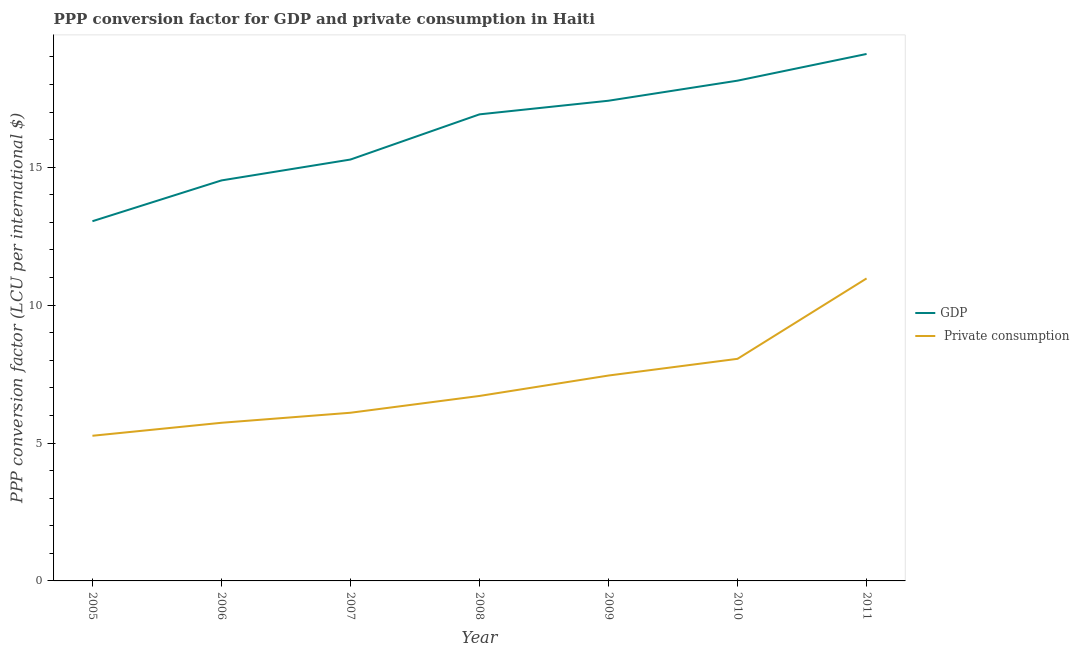How many different coloured lines are there?
Provide a short and direct response. 2. Is the number of lines equal to the number of legend labels?
Give a very brief answer. Yes. What is the ppp conversion factor for private consumption in 2011?
Your response must be concise. 10.97. Across all years, what is the maximum ppp conversion factor for gdp?
Provide a succinct answer. 19.11. Across all years, what is the minimum ppp conversion factor for gdp?
Keep it short and to the point. 13.04. In which year was the ppp conversion factor for gdp minimum?
Offer a very short reply. 2005. What is the total ppp conversion factor for gdp in the graph?
Offer a terse response. 114.43. What is the difference between the ppp conversion factor for private consumption in 2008 and that in 2011?
Offer a terse response. -4.26. What is the difference between the ppp conversion factor for private consumption in 2007 and the ppp conversion factor for gdp in 2008?
Make the answer very short. -10.82. What is the average ppp conversion factor for gdp per year?
Your response must be concise. 16.35. In the year 2011, what is the difference between the ppp conversion factor for private consumption and ppp conversion factor for gdp?
Make the answer very short. -8.14. What is the ratio of the ppp conversion factor for private consumption in 2007 to that in 2008?
Your answer should be compact. 0.91. Is the ppp conversion factor for private consumption in 2005 less than that in 2009?
Your answer should be very brief. Yes. Is the difference between the ppp conversion factor for private consumption in 2006 and 2007 greater than the difference between the ppp conversion factor for gdp in 2006 and 2007?
Offer a terse response. Yes. What is the difference between the highest and the second highest ppp conversion factor for gdp?
Ensure brevity in your answer.  0.97. What is the difference between the highest and the lowest ppp conversion factor for gdp?
Provide a short and direct response. 6.06. In how many years, is the ppp conversion factor for private consumption greater than the average ppp conversion factor for private consumption taken over all years?
Your answer should be compact. 3. Is the sum of the ppp conversion factor for private consumption in 2007 and 2011 greater than the maximum ppp conversion factor for gdp across all years?
Offer a very short reply. No. Is the ppp conversion factor for private consumption strictly less than the ppp conversion factor for gdp over the years?
Give a very brief answer. Yes. How many years are there in the graph?
Offer a terse response. 7. What is the difference between two consecutive major ticks on the Y-axis?
Provide a succinct answer. 5. Are the values on the major ticks of Y-axis written in scientific E-notation?
Offer a terse response. No. Does the graph contain grids?
Give a very brief answer. No. What is the title of the graph?
Keep it short and to the point. PPP conversion factor for GDP and private consumption in Haiti. Does "Taxes on exports" appear as one of the legend labels in the graph?
Your answer should be compact. No. What is the label or title of the Y-axis?
Your answer should be compact. PPP conversion factor (LCU per international $). What is the PPP conversion factor (LCU per international $) in GDP in 2005?
Offer a terse response. 13.04. What is the PPP conversion factor (LCU per international $) of  Private consumption in 2005?
Ensure brevity in your answer.  5.26. What is the PPP conversion factor (LCU per international $) in GDP in 2006?
Make the answer very short. 14.52. What is the PPP conversion factor (LCU per international $) in  Private consumption in 2006?
Make the answer very short. 5.73. What is the PPP conversion factor (LCU per international $) in GDP in 2007?
Your response must be concise. 15.28. What is the PPP conversion factor (LCU per international $) of  Private consumption in 2007?
Offer a terse response. 6.1. What is the PPP conversion factor (LCU per international $) of GDP in 2008?
Provide a succinct answer. 16.92. What is the PPP conversion factor (LCU per international $) in  Private consumption in 2008?
Give a very brief answer. 6.71. What is the PPP conversion factor (LCU per international $) of GDP in 2009?
Your answer should be compact. 17.41. What is the PPP conversion factor (LCU per international $) of  Private consumption in 2009?
Give a very brief answer. 7.45. What is the PPP conversion factor (LCU per international $) in GDP in 2010?
Give a very brief answer. 18.14. What is the PPP conversion factor (LCU per international $) of  Private consumption in 2010?
Make the answer very short. 8.05. What is the PPP conversion factor (LCU per international $) of GDP in 2011?
Keep it short and to the point. 19.11. What is the PPP conversion factor (LCU per international $) in  Private consumption in 2011?
Provide a succinct answer. 10.97. Across all years, what is the maximum PPP conversion factor (LCU per international $) of GDP?
Provide a succinct answer. 19.11. Across all years, what is the maximum PPP conversion factor (LCU per international $) in  Private consumption?
Offer a terse response. 10.97. Across all years, what is the minimum PPP conversion factor (LCU per international $) of GDP?
Provide a short and direct response. 13.04. Across all years, what is the minimum PPP conversion factor (LCU per international $) in  Private consumption?
Offer a very short reply. 5.26. What is the total PPP conversion factor (LCU per international $) in GDP in the graph?
Offer a terse response. 114.43. What is the total PPP conversion factor (LCU per international $) in  Private consumption in the graph?
Provide a succinct answer. 50.27. What is the difference between the PPP conversion factor (LCU per international $) in GDP in 2005 and that in 2006?
Give a very brief answer. -1.48. What is the difference between the PPP conversion factor (LCU per international $) of  Private consumption in 2005 and that in 2006?
Offer a very short reply. -0.47. What is the difference between the PPP conversion factor (LCU per international $) in GDP in 2005 and that in 2007?
Offer a terse response. -2.24. What is the difference between the PPP conversion factor (LCU per international $) of  Private consumption in 2005 and that in 2007?
Your answer should be compact. -0.83. What is the difference between the PPP conversion factor (LCU per international $) of GDP in 2005 and that in 2008?
Keep it short and to the point. -3.88. What is the difference between the PPP conversion factor (LCU per international $) of  Private consumption in 2005 and that in 2008?
Give a very brief answer. -1.44. What is the difference between the PPP conversion factor (LCU per international $) in GDP in 2005 and that in 2009?
Your answer should be very brief. -4.37. What is the difference between the PPP conversion factor (LCU per international $) of  Private consumption in 2005 and that in 2009?
Give a very brief answer. -2.18. What is the difference between the PPP conversion factor (LCU per international $) in GDP in 2005 and that in 2010?
Your response must be concise. -5.1. What is the difference between the PPP conversion factor (LCU per international $) in  Private consumption in 2005 and that in 2010?
Make the answer very short. -2.79. What is the difference between the PPP conversion factor (LCU per international $) in GDP in 2005 and that in 2011?
Your response must be concise. -6.06. What is the difference between the PPP conversion factor (LCU per international $) of  Private consumption in 2005 and that in 2011?
Your response must be concise. -5.71. What is the difference between the PPP conversion factor (LCU per international $) of GDP in 2006 and that in 2007?
Offer a very short reply. -0.76. What is the difference between the PPP conversion factor (LCU per international $) of  Private consumption in 2006 and that in 2007?
Make the answer very short. -0.36. What is the difference between the PPP conversion factor (LCU per international $) of GDP in 2006 and that in 2008?
Your answer should be compact. -2.4. What is the difference between the PPP conversion factor (LCU per international $) in  Private consumption in 2006 and that in 2008?
Offer a terse response. -0.97. What is the difference between the PPP conversion factor (LCU per international $) in GDP in 2006 and that in 2009?
Keep it short and to the point. -2.89. What is the difference between the PPP conversion factor (LCU per international $) of  Private consumption in 2006 and that in 2009?
Offer a terse response. -1.71. What is the difference between the PPP conversion factor (LCU per international $) of GDP in 2006 and that in 2010?
Provide a succinct answer. -3.62. What is the difference between the PPP conversion factor (LCU per international $) of  Private consumption in 2006 and that in 2010?
Provide a succinct answer. -2.32. What is the difference between the PPP conversion factor (LCU per international $) in GDP in 2006 and that in 2011?
Give a very brief answer. -4.59. What is the difference between the PPP conversion factor (LCU per international $) in  Private consumption in 2006 and that in 2011?
Give a very brief answer. -5.23. What is the difference between the PPP conversion factor (LCU per international $) of GDP in 2007 and that in 2008?
Provide a short and direct response. -1.64. What is the difference between the PPP conversion factor (LCU per international $) of  Private consumption in 2007 and that in 2008?
Provide a succinct answer. -0.61. What is the difference between the PPP conversion factor (LCU per international $) of GDP in 2007 and that in 2009?
Keep it short and to the point. -2.13. What is the difference between the PPP conversion factor (LCU per international $) in  Private consumption in 2007 and that in 2009?
Ensure brevity in your answer.  -1.35. What is the difference between the PPP conversion factor (LCU per international $) in GDP in 2007 and that in 2010?
Offer a very short reply. -2.86. What is the difference between the PPP conversion factor (LCU per international $) of  Private consumption in 2007 and that in 2010?
Your response must be concise. -1.96. What is the difference between the PPP conversion factor (LCU per international $) in GDP in 2007 and that in 2011?
Offer a very short reply. -3.83. What is the difference between the PPP conversion factor (LCU per international $) in  Private consumption in 2007 and that in 2011?
Offer a very short reply. -4.87. What is the difference between the PPP conversion factor (LCU per international $) of GDP in 2008 and that in 2009?
Make the answer very short. -0.49. What is the difference between the PPP conversion factor (LCU per international $) of  Private consumption in 2008 and that in 2009?
Your response must be concise. -0.74. What is the difference between the PPP conversion factor (LCU per international $) of GDP in 2008 and that in 2010?
Your answer should be very brief. -1.22. What is the difference between the PPP conversion factor (LCU per international $) in  Private consumption in 2008 and that in 2010?
Provide a succinct answer. -1.35. What is the difference between the PPP conversion factor (LCU per international $) of GDP in 2008 and that in 2011?
Keep it short and to the point. -2.19. What is the difference between the PPP conversion factor (LCU per international $) in  Private consumption in 2008 and that in 2011?
Give a very brief answer. -4.26. What is the difference between the PPP conversion factor (LCU per international $) in GDP in 2009 and that in 2010?
Provide a short and direct response. -0.73. What is the difference between the PPP conversion factor (LCU per international $) in  Private consumption in 2009 and that in 2010?
Provide a succinct answer. -0.61. What is the difference between the PPP conversion factor (LCU per international $) of GDP in 2009 and that in 2011?
Provide a short and direct response. -1.7. What is the difference between the PPP conversion factor (LCU per international $) of  Private consumption in 2009 and that in 2011?
Keep it short and to the point. -3.52. What is the difference between the PPP conversion factor (LCU per international $) of GDP in 2010 and that in 2011?
Provide a short and direct response. -0.97. What is the difference between the PPP conversion factor (LCU per international $) of  Private consumption in 2010 and that in 2011?
Provide a succinct answer. -2.91. What is the difference between the PPP conversion factor (LCU per international $) in GDP in 2005 and the PPP conversion factor (LCU per international $) in  Private consumption in 2006?
Ensure brevity in your answer.  7.31. What is the difference between the PPP conversion factor (LCU per international $) of GDP in 2005 and the PPP conversion factor (LCU per international $) of  Private consumption in 2007?
Provide a short and direct response. 6.95. What is the difference between the PPP conversion factor (LCU per international $) of GDP in 2005 and the PPP conversion factor (LCU per international $) of  Private consumption in 2008?
Provide a succinct answer. 6.34. What is the difference between the PPP conversion factor (LCU per international $) in GDP in 2005 and the PPP conversion factor (LCU per international $) in  Private consumption in 2009?
Provide a succinct answer. 5.6. What is the difference between the PPP conversion factor (LCU per international $) in GDP in 2005 and the PPP conversion factor (LCU per international $) in  Private consumption in 2010?
Your answer should be compact. 4.99. What is the difference between the PPP conversion factor (LCU per international $) in GDP in 2005 and the PPP conversion factor (LCU per international $) in  Private consumption in 2011?
Provide a short and direct response. 2.07. What is the difference between the PPP conversion factor (LCU per international $) in GDP in 2006 and the PPP conversion factor (LCU per international $) in  Private consumption in 2007?
Your response must be concise. 8.42. What is the difference between the PPP conversion factor (LCU per international $) in GDP in 2006 and the PPP conversion factor (LCU per international $) in  Private consumption in 2008?
Give a very brief answer. 7.82. What is the difference between the PPP conversion factor (LCU per international $) of GDP in 2006 and the PPP conversion factor (LCU per international $) of  Private consumption in 2009?
Offer a very short reply. 7.07. What is the difference between the PPP conversion factor (LCU per international $) of GDP in 2006 and the PPP conversion factor (LCU per international $) of  Private consumption in 2010?
Your answer should be compact. 6.47. What is the difference between the PPP conversion factor (LCU per international $) of GDP in 2006 and the PPP conversion factor (LCU per international $) of  Private consumption in 2011?
Make the answer very short. 3.55. What is the difference between the PPP conversion factor (LCU per international $) in GDP in 2007 and the PPP conversion factor (LCU per international $) in  Private consumption in 2008?
Give a very brief answer. 8.57. What is the difference between the PPP conversion factor (LCU per international $) of GDP in 2007 and the PPP conversion factor (LCU per international $) of  Private consumption in 2009?
Offer a terse response. 7.83. What is the difference between the PPP conversion factor (LCU per international $) in GDP in 2007 and the PPP conversion factor (LCU per international $) in  Private consumption in 2010?
Your answer should be compact. 7.23. What is the difference between the PPP conversion factor (LCU per international $) in GDP in 2007 and the PPP conversion factor (LCU per international $) in  Private consumption in 2011?
Keep it short and to the point. 4.31. What is the difference between the PPP conversion factor (LCU per international $) in GDP in 2008 and the PPP conversion factor (LCU per international $) in  Private consumption in 2009?
Give a very brief answer. 9.47. What is the difference between the PPP conversion factor (LCU per international $) of GDP in 2008 and the PPP conversion factor (LCU per international $) of  Private consumption in 2010?
Keep it short and to the point. 8.86. What is the difference between the PPP conversion factor (LCU per international $) of GDP in 2008 and the PPP conversion factor (LCU per international $) of  Private consumption in 2011?
Ensure brevity in your answer.  5.95. What is the difference between the PPP conversion factor (LCU per international $) of GDP in 2009 and the PPP conversion factor (LCU per international $) of  Private consumption in 2010?
Your response must be concise. 9.36. What is the difference between the PPP conversion factor (LCU per international $) in GDP in 2009 and the PPP conversion factor (LCU per international $) in  Private consumption in 2011?
Give a very brief answer. 6.44. What is the difference between the PPP conversion factor (LCU per international $) in GDP in 2010 and the PPP conversion factor (LCU per international $) in  Private consumption in 2011?
Keep it short and to the point. 7.17. What is the average PPP conversion factor (LCU per international $) in GDP per year?
Ensure brevity in your answer.  16.35. What is the average PPP conversion factor (LCU per international $) of  Private consumption per year?
Your answer should be compact. 7.18. In the year 2005, what is the difference between the PPP conversion factor (LCU per international $) of GDP and PPP conversion factor (LCU per international $) of  Private consumption?
Give a very brief answer. 7.78. In the year 2006, what is the difference between the PPP conversion factor (LCU per international $) in GDP and PPP conversion factor (LCU per international $) in  Private consumption?
Ensure brevity in your answer.  8.79. In the year 2007, what is the difference between the PPP conversion factor (LCU per international $) of GDP and PPP conversion factor (LCU per international $) of  Private consumption?
Provide a succinct answer. 9.18. In the year 2008, what is the difference between the PPP conversion factor (LCU per international $) of GDP and PPP conversion factor (LCU per international $) of  Private consumption?
Offer a terse response. 10.21. In the year 2009, what is the difference between the PPP conversion factor (LCU per international $) of GDP and PPP conversion factor (LCU per international $) of  Private consumption?
Offer a very short reply. 9.96. In the year 2010, what is the difference between the PPP conversion factor (LCU per international $) in GDP and PPP conversion factor (LCU per international $) in  Private consumption?
Provide a short and direct response. 10.09. In the year 2011, what is the difference between the PPP conversion factor (LCU per international $) of GDP and PPP conversion factor (LCU per international $) of  Private consumption?
Offer a very short reply. 8.14. What is the ratio of the PPP conversion factor (LCU per international $) in GDP in 2005 to that in 2006?
Your answer should be very brief. 0.9. What is the ratio of the PPP conversion factor (LCU per international $) in  Private consumption in 2005 to that in 2006?
Make the answer very short. 0.92. What is the ratio of the PPP conversion factor (LCU per international $) in GDP in 2005 to that in 2007?
Your answer should be compact. 0.85. What is the ratio of the PPP conversion factor (LCU per international $) of  Private consumption in 2005 to that in 2007?
Ensure brevity in your answer.  0.86. What is the ratio of the PPP conversion factor (LCU per international $) in GDP in 2005 to that in 2008?
Provide a succinct answer. 0.77. What is the ratio of the PPP conversion factor (LCU per international $) of  Private consumption in 2005 to that in 2008?
Offer a terse response. 0.78. What is the ratio of the PPP conversion factor (LCU per international $) in GDP in 2005 to that in 2009?
Ensure brevity in your answer.  0.75. What is the ratio of the PPP conversion factor (LCU per international $) in  Private consumption in 2005 to that in 2009?
Your response must be concise. 0.71. What is the ratio of the PPP conversion factor (LCU per international $) of GDP in 2005 to that in 2010?
Keep it short and to the point. 0.72. What is the ratio of the PPP conversion factor (LCU per international $) in  Private consumption in 2005 to that in 2010?
Your response must be concise. 0.65. What is the ratio of the PPP conversion factor (LCU per international $) of GDP in 2005 to that in 2011?
Offer a very short reply. 0.68. What is the ratio of the PPP conversion factor (LCU per international $) in  Private consumption in 2005 to that in 2011?
Provide a succinct answer. 0.48. What is the ratio of the PPP conversion factor (LCU per international $) of GDP in 2006 to that in 2007?
Your answer should be compact. 0.95. What is the ratio of the PPP conversion factor (LCU per international $) in  Private consumption in 2006 to that in 2007?
Give a very brief answer. 0.94. What is the ratio of the PPP conversion factor (LCU per international $) of GDP in 2006 to that in 2008?
Offer a terse response. 0.86. What is the ratio of the PPP conversion factor (LCU per international $) of  Private consumption in 2006 to that in 2008?
Ensure brevity in your answer.  0.85. What is the ratio of the PPP conversion factor (LCU per international $) of GDP in 2006 to that in 2009?
Make the answer very short. 0.83. What is the ratio of the PPP conversion factor (LCU per international $) of  Private consumption in 2006 to that in 2009?
Make the answer very short. 0.77. What is the ratio of the PPP conversion factor (LCU per international $) of GDP in 2006 to that in 2010?
Provide a succinct answer. 0.8. What is the ratio of the PPP conversion factor (LCU per international $) in  Private consumption in 2006 to that in 2010?
Offer a terse response. 0.71. What is the ratio of the PPP conversion factor (LCU per international $) in GDP in 2006 to that in 2011?
Offer a terse response. 0.76. What is the ratio of the PPP conversion factor (LCU per international $) of  Private consumption in 2006 to that in 2011?
Offer a terse response. 0.52. What is the ratio of the PPP conversion factor (LCU per international $) of GDP in 2007 to that in 2008?
Your response must be concise. 0.9. What is the ratio of the PPP conversion factor (LCU per international $) of  Private consumption in 2007 to that in 2008?
Your answer should be very brief. 0.91. What is the ratio of the PPP conversion factor (LCU per international $) of GDP in 2007 to that in 2009?
Provide a short and direct response. 0.88. What is the ratio of the PPP conversion factor (LCU per international $) of  Private consumption in 2007 to that in 2009?
Offer a very short reply. 0.82. What is the ratio of the PPP conversion factor (LCU per international $) in GDP in 2007 to that in 2010?
Offer a terse response. 0.84. What is the ratio of the PPP conversion factor (LCU per international $) in  Private consumption in 2007 to that in 2010?
Give a very brief answer. 0.76. What is the ratio of the PPP conversion factor (LCU per international $) of GDP in 2007 to that in 2011?
Make the answer very short. 0.8. What is the ratio of the PPP conversion factor (LCU per international $) of  Private consumption in 2007 to that in 2011?
Offer a terse response. 0.56. What is the ratio of the PPP conversion factor (LCU per international $) in GDP in 2008 to that in 2009?
Keep it short and to the point. 0.97. What is the ratio of the PPP conversion factor (LCU per international $) of  Private consumption in 2008 to that in 2009?
Keep it short and to the point. 0.9. What is the ratio of the PPP conversion factor (LCU per international $) of GDP in 2008 to that in 2010?
Your answer should be compact. 0.93. What is the ratio of the PPP conversion factor (LCU per international $) of  Private consumption in 2008 to that in 2010?
Keep it short and to the point. 0.83. What is the ratio of the PPP conversion factor (LCU per international $) in GDP in 2008 to that in 2011?
Offer a very short reply. 0.89. What is the ratio of the PPP conversion factor (LCU per international $) in  Private consumption in 2008 to that in 2011?
Provide a short and direct response. 0.61. What is the ratio of the PPP conversion factor (LCU per international $) of GDP in 2009 to that in 2010?
Provide a succinct answer. 0.96. What is the ratio of the PPP conversion factor (LCU per international $) in  Private consumption in 2009 to that in 2010?
Offer a terse response. 0.92. What is the ratio of the PPP conversion factor (LCU per international $) of GDP in 2009 to that in 2011?
Your answer should be very brief. 0.91. What is the ratio of the PPP conversion factor (LCU per international $) in  Private consumption in 2009 to that in 2011?
Your answer should be compact. 0.68. What is the ratio of the PPP conversion factor (LCU per international $) in GDP in 2010 to that in 2011?
Your answer should be very brief. 0.95. What is the ratio of the PPP conversion factor (LCU per international $) of  Private consumption in 2010 to that in 2011?
Give a very brief answer. 0.73. What is the difference between the highest and the second highest PPP conversion factor (LCU per international $) in GDP?
Keep it short and to the point. 0.97. What is the difference between the highest and the second highest PPP conversion factor (LCU per international $) of  Private consumption?
Provide a succinct answer. 2.91. What is the difference between the highest and the lowest PPP conversion factor (LCU per international $) of GDP?
Your response must be concise. 6.06. What is the difference between the highest and the lowest PPP conversion factor (LCU per international $) in  Private consumption?
Your answer should be compact. 5.71. 